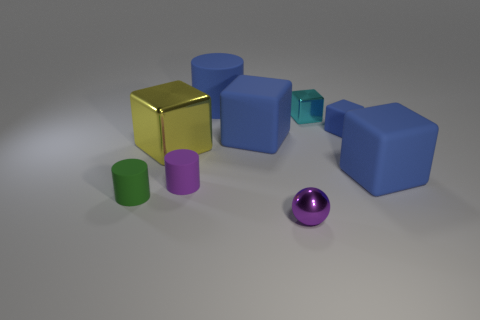Is the number of large cubes that are to the left of the large blue cylinder the same as the number of cyan blocks that are in front of the cyan block?
Your answer should be compact. No. The large object that is the same material as the small sphere is what color?
Your response must be concise. Yellow. Does the large metal thing have the same color as the tiny rubber cylinder that is on the right side of the small green rubber cylinder?
Give a very brief answer. No. There is a blue cube that is to the left of the tiny cube that is in front of the cyan shiny cube; is there a large metal thing behind it?
Your answer should be compact. No. There is a yellow thing that is made of the same material as the tiny cyan thing; what is its shape?
Make the answer very short. Cube. Are there any other things that have the same shape as the big metallic object?
Provide a short and direct response. Yes. The small green rubber object has what shape?
Provide a short and direct response. Cylinder. There is a tiny purple metal object that is in front of the small purple cylinder; is it the same shape as the green thing?
Your response must be concise. No. Are there more metallic things that are behind the small cyan thing than large blue cylinders on the left side of the tiny purple cylinder?
Make the answer very short. No. How many other things are the same size as the cyan object?
Offer a very short reply. 4. 